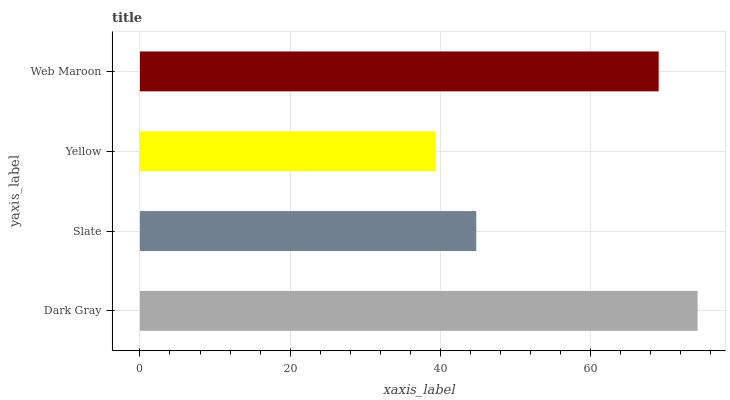Is Yellow the minimum?
Answer yes or no. Yes. Is Dark Gray the maximum?
Answer yes or no. Yes. Is Slate the minimum?
Answer yes or no. No. Is Slate the maximum?
Answer yes or no. No. Is Dark Gray greater than Slate?
Answer yes or no. Yes. Is Slate less than Dark Gray?
Answer yes or no. Yes. Is Slate greater than Dark Gray?
Answer yes or no. No. Is Dark Gray less than Slate?
Answer yes or no. No. Is Web Maroon the high median?
Answer yes or no. Yes. Is Slate the low median?
Answer yes or no. Yes. Is Yellow the high median?
Answer yes or no. No. Is Web Maroon the low median?
Answer yes or no. No. 